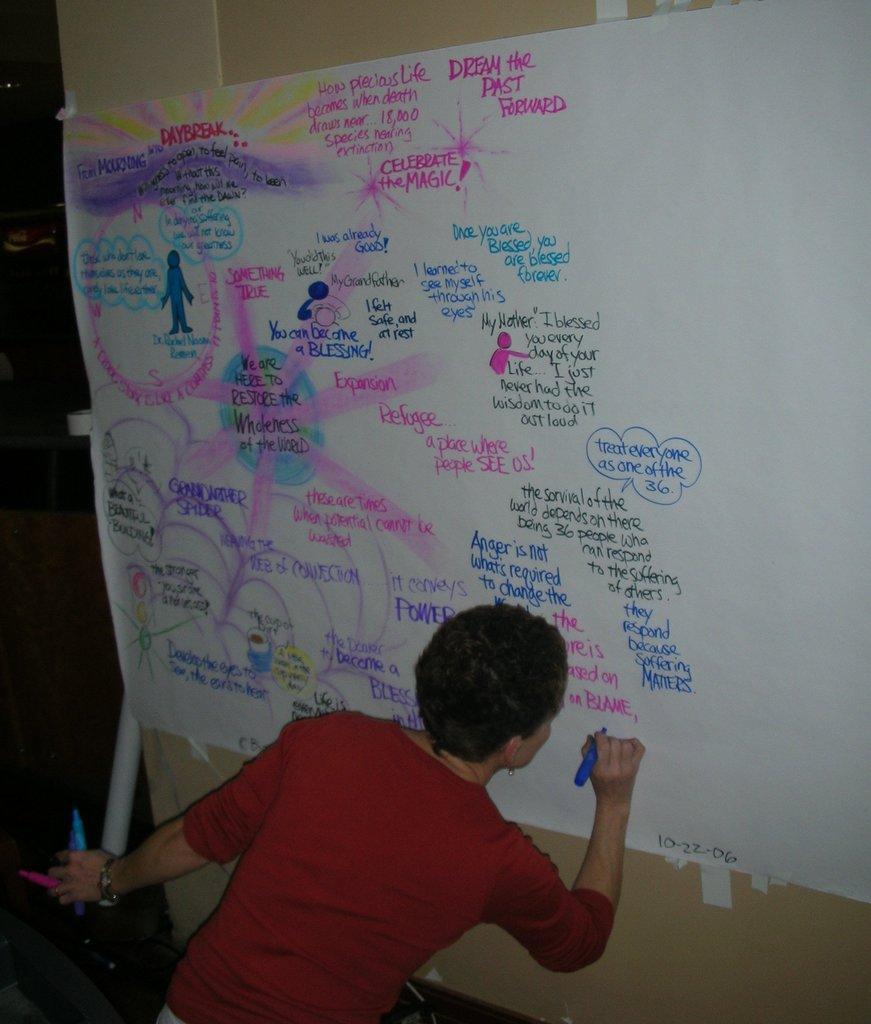Can you describe this image briefly? In this image we can see a person writing on the chart. There is a rolled chart at the left side of the image. A person is holding few pens in his hands. 